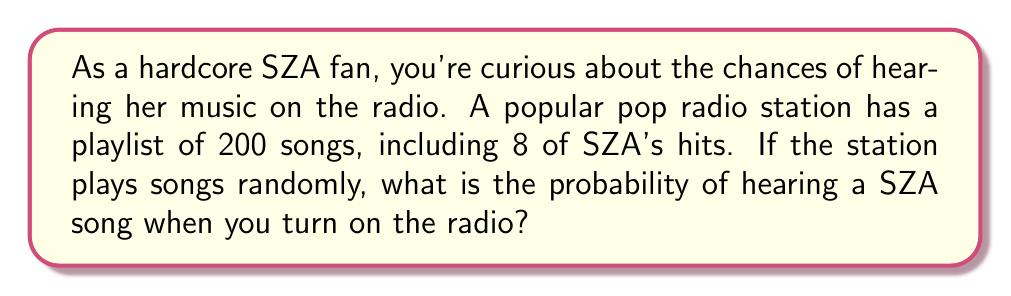Can you answer this question? To solve this problem, we need to use the concept of probability. The probability of an event occurring is the number of favorable outcomes divided by the total number of possible outcomes, assuming all outcomes are equally likely.

In this case:
- Total number of songs in the playlist: 200
- Number of SZA songs in the playlist: 8

The probability of hearing a SZA song is:

$$P(\text{SZA song}) = \frac{\text{Number of SZA songs}}{\text{Total number of songs}}$$

$$P(\text{SZA song}) = \frac{8}{200}$$

To simplify this fraction:

$$P(\text{SZA song}) = \frac{8}{200} = \frac{4}{100} = 0.04$$

We can also express this as a percentage:

$$0.04 \times 100\% = 4\%$$

Therefore, the probability of hearing a SZA song when you turn on this radio station is 0.04 or 4%.
Answer: $\frac{1}{25}$ or $0.04$ or $4\%$ 